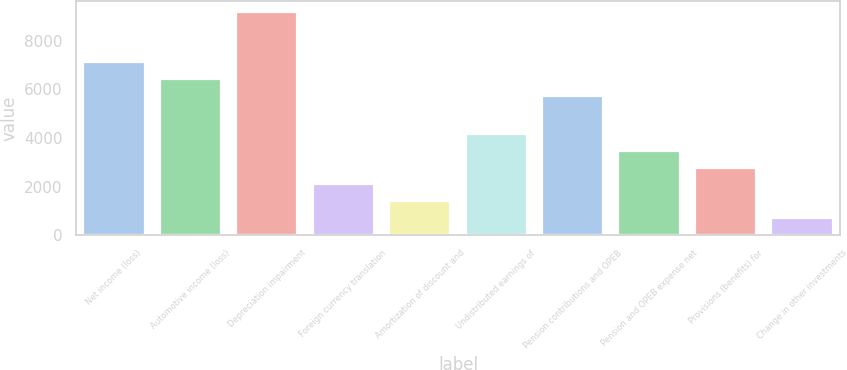Convert chart to OTSL. <chart><loc_0><loc_0><loc_500><loc_500><bar_chart><fcel>Net income (loss)<fcel>Automotive income (loss)<fcel>Depreciation impairment<fcel>Foreign currency translation<fcel>Amortization of discount and<fcel>Undistributed earnings of<fcel>Pension contributions and OPEB<fcel>Pension and OPEB expense net<fcel>Provisions (benefits) for<fcel>Change in other investments<nl><fcel>7104.2<fcel>6413.6<fcel>9176<fcel>2088.8<fcel>1398.2<fcel>4160.6<fcel>5723<fcel>3470<fcel>2779.4<fcel>707.6<nl></chart> 